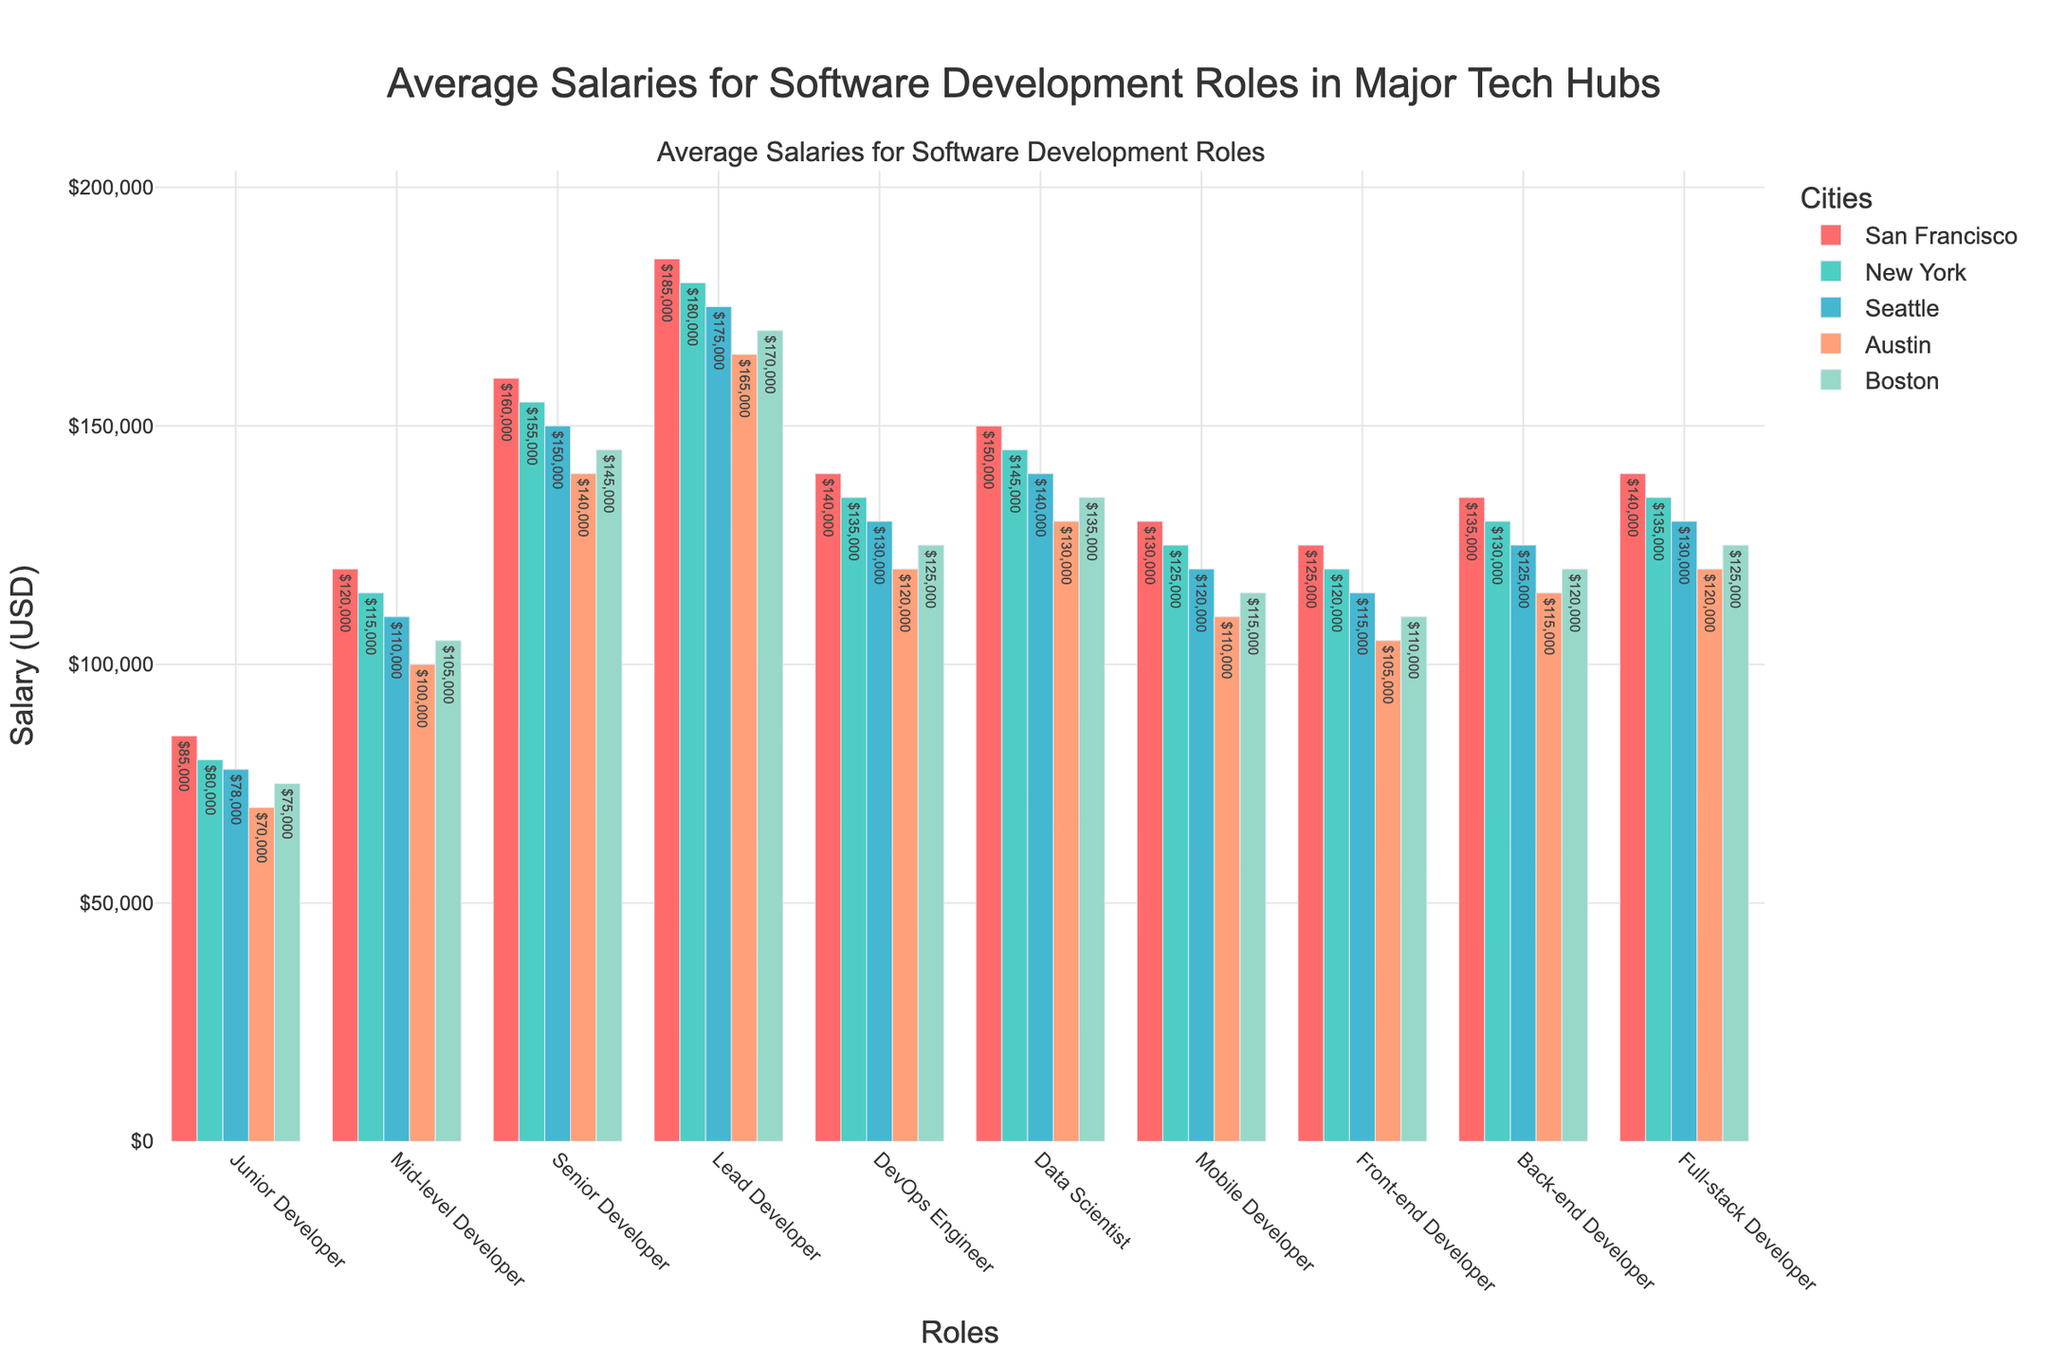What's the highest average salary for any role in San Francisco? San Francisco highest average salary is found by identifying the largest value in its column. The highest value is $185,000 for Lead Developer.
Answer: $185,000 Which city offers the highest salary for a Mid-level Developer? To determine this, we compare the salaries of Mid-level Developers across all listed cities. San Francisco offers the highest salary of $120,000.
Answer: San Francisco What is the difference in salary between a Senior Developer and a Junior Developer in Boston? Subtract the Junior Developer salary from the Senior Developer salary in Boston. $145,000 - $75,000 = $70,000.
Answer: $70,000 Which role has the smallest salary difference between New York and Austin? Compute the absolute differences for each role and identify the smallest one. Mobile Developer has the smallest difference: $125,000 (NY) - $110,000 (Austin) = $15,000.
Answer: Mobile Developer What is the average salary of a DevOps Engineer across all cities? Sum the salaries for DevOps Engineer in all cities and divide by the number of cities. ($140,000 + $135,000 + $130,000 + $120,000 + $125,000) / 5 = $130,000.
Answer: $130,000 How much more does a Lead Developer make in Austin compared to a Front-end Developer in the same city? Subtract the salary of Front-end Developer from Lead Developer in Austin. $165,000 - $105,000 = $60,000.
Answer: $60,000 What is the total salary for a Full-stack Developer in San Francisco and New York? Add the Full-stack Developer salaries in San Francisco and New York. $140,000 + $135,000 = $275,000.
Answer: $275,000 Which city offers the lowest salary for a Back-end Developer and what is it? Identify the smallest salary in the Back-end Developer row. Austin offers the lowest salary at $115,000.
Answer: Austin, $115,000 Which role has the highest salary in Seattle, and what is that salary? Find the highest value in the Seattle column. The highest salary is for the Lead Developer at $175,000.
Answer: Lead Developer, $175,000 